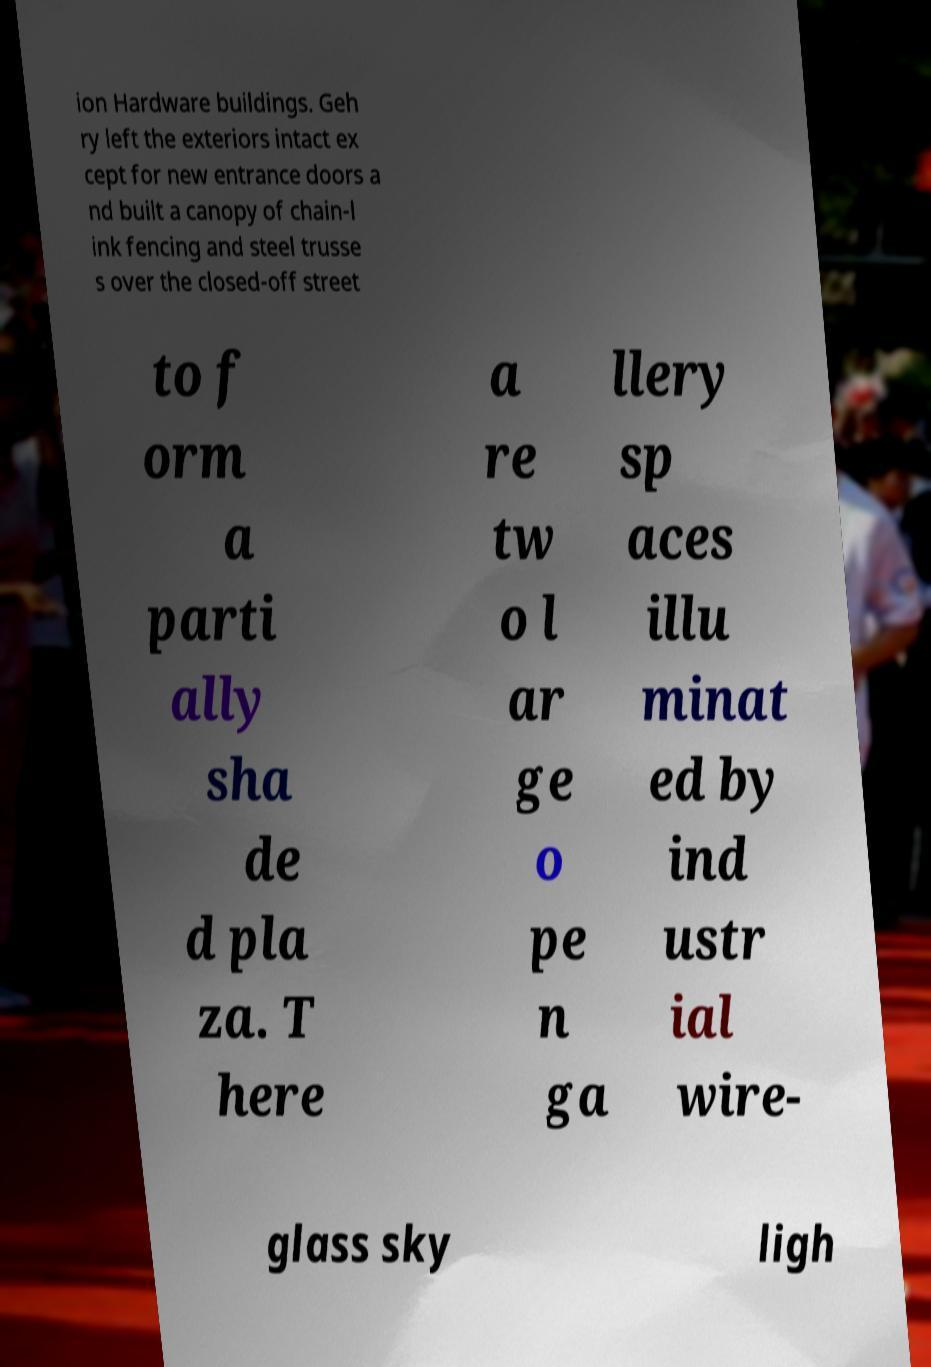Please identify and transcribe the text found in this image. ion Hardware buildings. Geh ry left the exteriors intact ex cept for new entrance doors a nd built a canopy of chain-l ink fencing and steel trusse s over the closed-off street to f orm a parti ally sha de d pla za. T here a re tw o l ar ge o pe n ga llery sp aces illu minat ed by ind ustr ial wire- glass sky ligh 